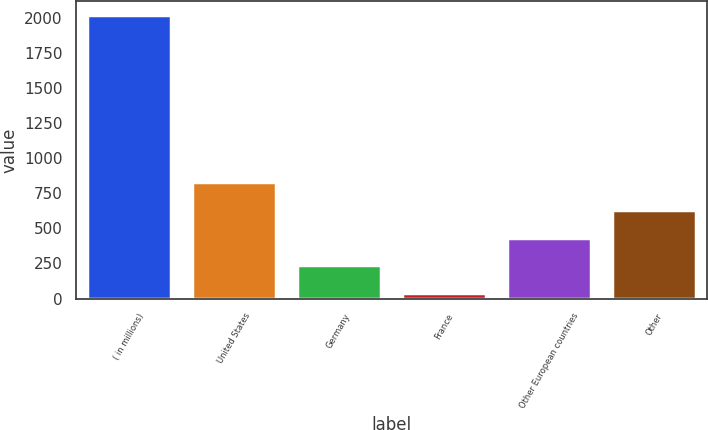Convert chart to OTSL. <chart><loc_0><loc_0><loc_500><loc_500><bar_chart><fcel>( in millions)<fcel>United States<fcel>Germany<fcel>France<fcel>Other European countries<fcel>Other<nl><fcel>2015<fcel>829.16<fcel>236.24<fcel>38.6<fcel>433.88<fcel>631.52<nl></chart> 